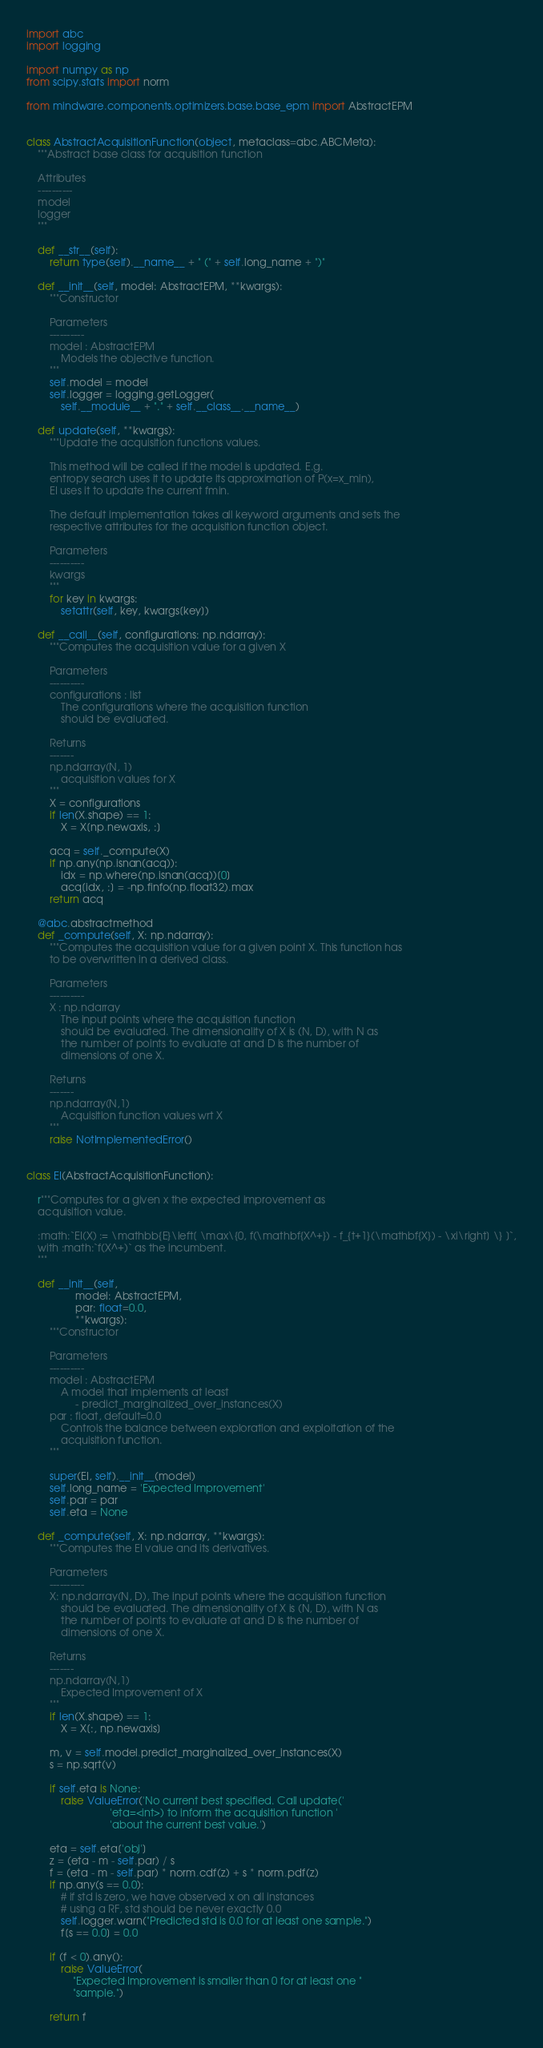<code> <loc_0><loc_0><loc_500><loc_500><_Python_>import abc
import logging

import numpy as np
from scipy.stats import norm

from mindware.components.optimizers.base.base_epm import AbstractEPM


class AbstractAcquisitionFunction(object, metaclass=abc.ABCMeta):
    """Abstract base class for acquisition function

    Attributes
    ----------
    model
    logger
    """

    def __str__(self):
        return type(self).__name__ + " (" + self.long_name + ")"

    def __init__(self, model: AbstractEPM, **kwargs):
        """Constructor

        Parameters
        ----------
        model : AbstractEPM
            Models the objective function.
        """
        self.model = model
        self.logger = logging.getLogger(
            self.__module__ + "." + self.__class__.__name__)

    def update(self, **kwargs):
        """Update the acquisition functions values.

        This method will be called if the model is updated. E.g.
        entropy search uses it to update its approximation of P(x=x_min),
        EI uses it to update the current fmin.

        The default implementation takes all keyword arguments and sets the
        respective attributes for the acquisition function object.

        Parameters
        ----------
        kwargs
        """
        for key in kwargs:
            setattr(self, key, kwargs[key])

    def __call__(self, configurations: np.ndarray):
        """Computes the acquisition value for a given X

        Parameters
        ----------
        configurations : list
            The configurations where the acquisition function
            should be evaluated.

        Returns
        -------
        np.ndarray(N, 1)
            acquisition values for X
        """
        X = configurations
        if len(X.shape) == 1:
            X = X[np.newaxis, :]

        acq = self._compute(X)
        if np.any(np.isnan(acq)):
            idx = np.where(np.isnan(acq))[0]
            acq[idx, :] = -np.finfo(np.float32).max
        return acq

    @abc.abstractmethod
    def _compute(self, X: np.ndarray):
        """Computes the acquisition value for a given point X. This function has
        to be overwritten in a derived class.

        Parameters
        ----------
        X : np.ndarray
            The input points where the acquisition function
            should be evaluated. The dimensionality of X is (N, D), with N as
            the number of points to evaluate at and D is the number of
            dimensions of one X.

        Returns
        -------
        np.ndarray(N,1)
            Acquisition function values wrt X
        """
        raise NotImplementedError()


class EI(AbstractAcquisitionFunction):

    r"""Computes for a given x the expected improvement as
    acquisition value.

    :math:`EI(X) := \mathbb{E}\left[ \max\{0, f(\mathbf{X^+}) - f_{t+1}(\mathbf{X}) - \xi\right] \} ]`,
    with :math:`f(X^+)` as the incumbent.
    """

    def __init__(self,
                 model: AbstractEPM,
                 par: float=0.0,
                 **kwargs):
        """Constructor

        Parameters
        ----------
        model : AbstractEPM
            A model that implements at least
                 - predict_marginalized_over_instances(X)
        par : float, default=0.0
            Controls the balance between exploration and exploitation of the
            acquisition function.
        """

        super(EI, self).__init__(model)
        self.long_name = 'Expected Improvement'
        self.par = par
        self.eta = None

    def _compute(self, X: np.ndarray, **kwargs):
        """Computes the EI value and its derivatives.

        Parameters
        ----------
        X: np.ndarray(N, D), The input points where the acquisition function
            should be evaluated. The dimensionality of X is (N, D), with N as
            the number of points to evaluate at and D is the number of
            dimensions of one X.

        Returns
        -------
        np.ndarray(N,1)
            Expected Improvement of X
        """
        if len(X.shape) == 1:
            X = X[:, np.newaxis]

        m, v = self.model.predict_marginalized_over_instances(X)
        s = np.sqrt(v)

        if self.eta is None:
            raise ValueError('No current best specified. Call update('
                             'eta=<int>) to inform the acquisition function '
                             'about the current best value.')

        eta = self.eta['obj']
        z = (eta - m - self.par) / s
        f = (eta - m - self.par) * norm.cdf(z) + s * norm.pdf(z)
        if np.any(s == 0.0):
            # if std is zero, we have observed x on all instances
            # using a RF, std should be never exactly 0.0
            self.logger.warn("Predicted std is 0.0 for at least one sample.")
            f[s == 0.0] = 0.0

        if (f < 0).any():
            raise ValueError(
                "Expected Improvement is smaller than 0 for at least one "
                "sample.")

        return f
</code> 